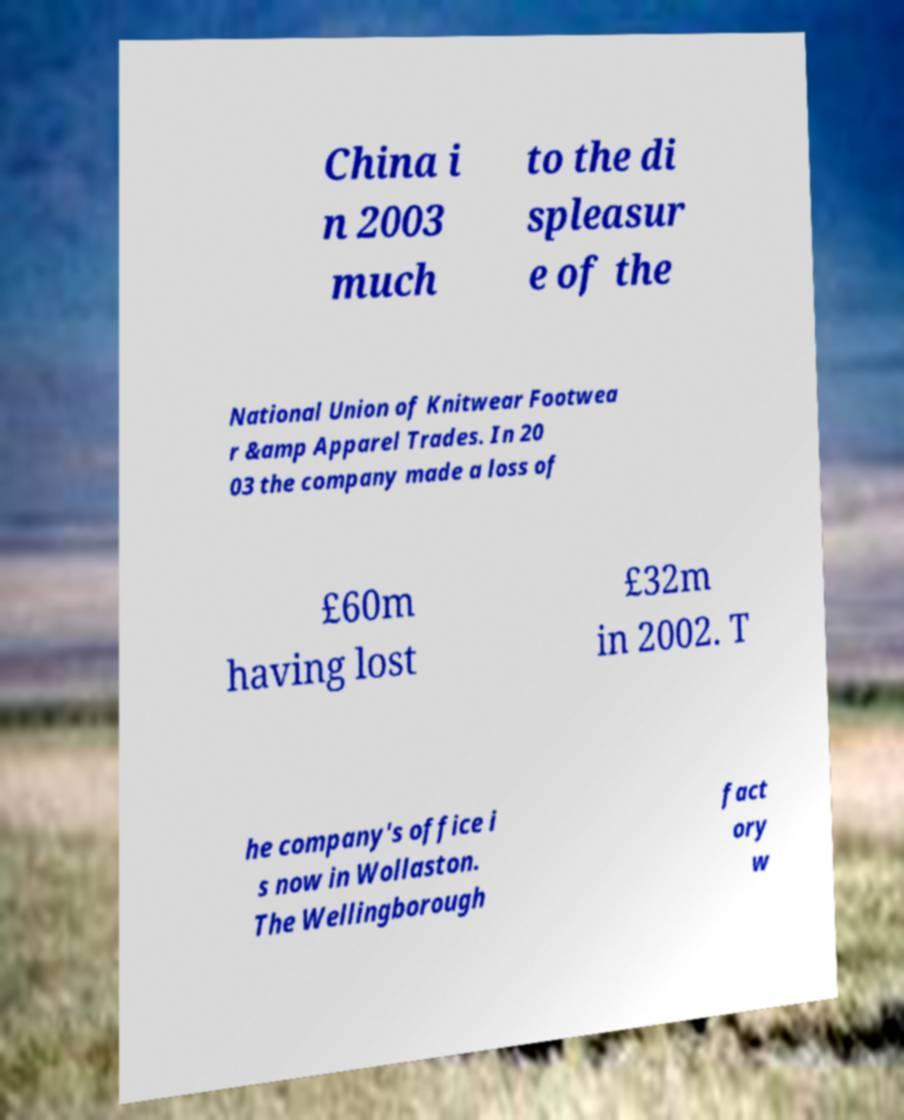Please identify and transcribe the text found in this image. China i n 2003 much to the di spleasur e of the National Union of Knitwear Footwea r &amp Apparel Trades. In 20 03 the company made a loss of £60m having lost £32m in 2002. T he company's office i s now in Wollaston. The Wellingborough fact ory w 